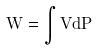Convert formula to latex. <formula><loc_0><loc_0><loc_500><loc_500>W = \int V d P</formula> 